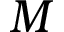<formula> <loc_0><loc_0><loc_500><loc_500>M</formula> 